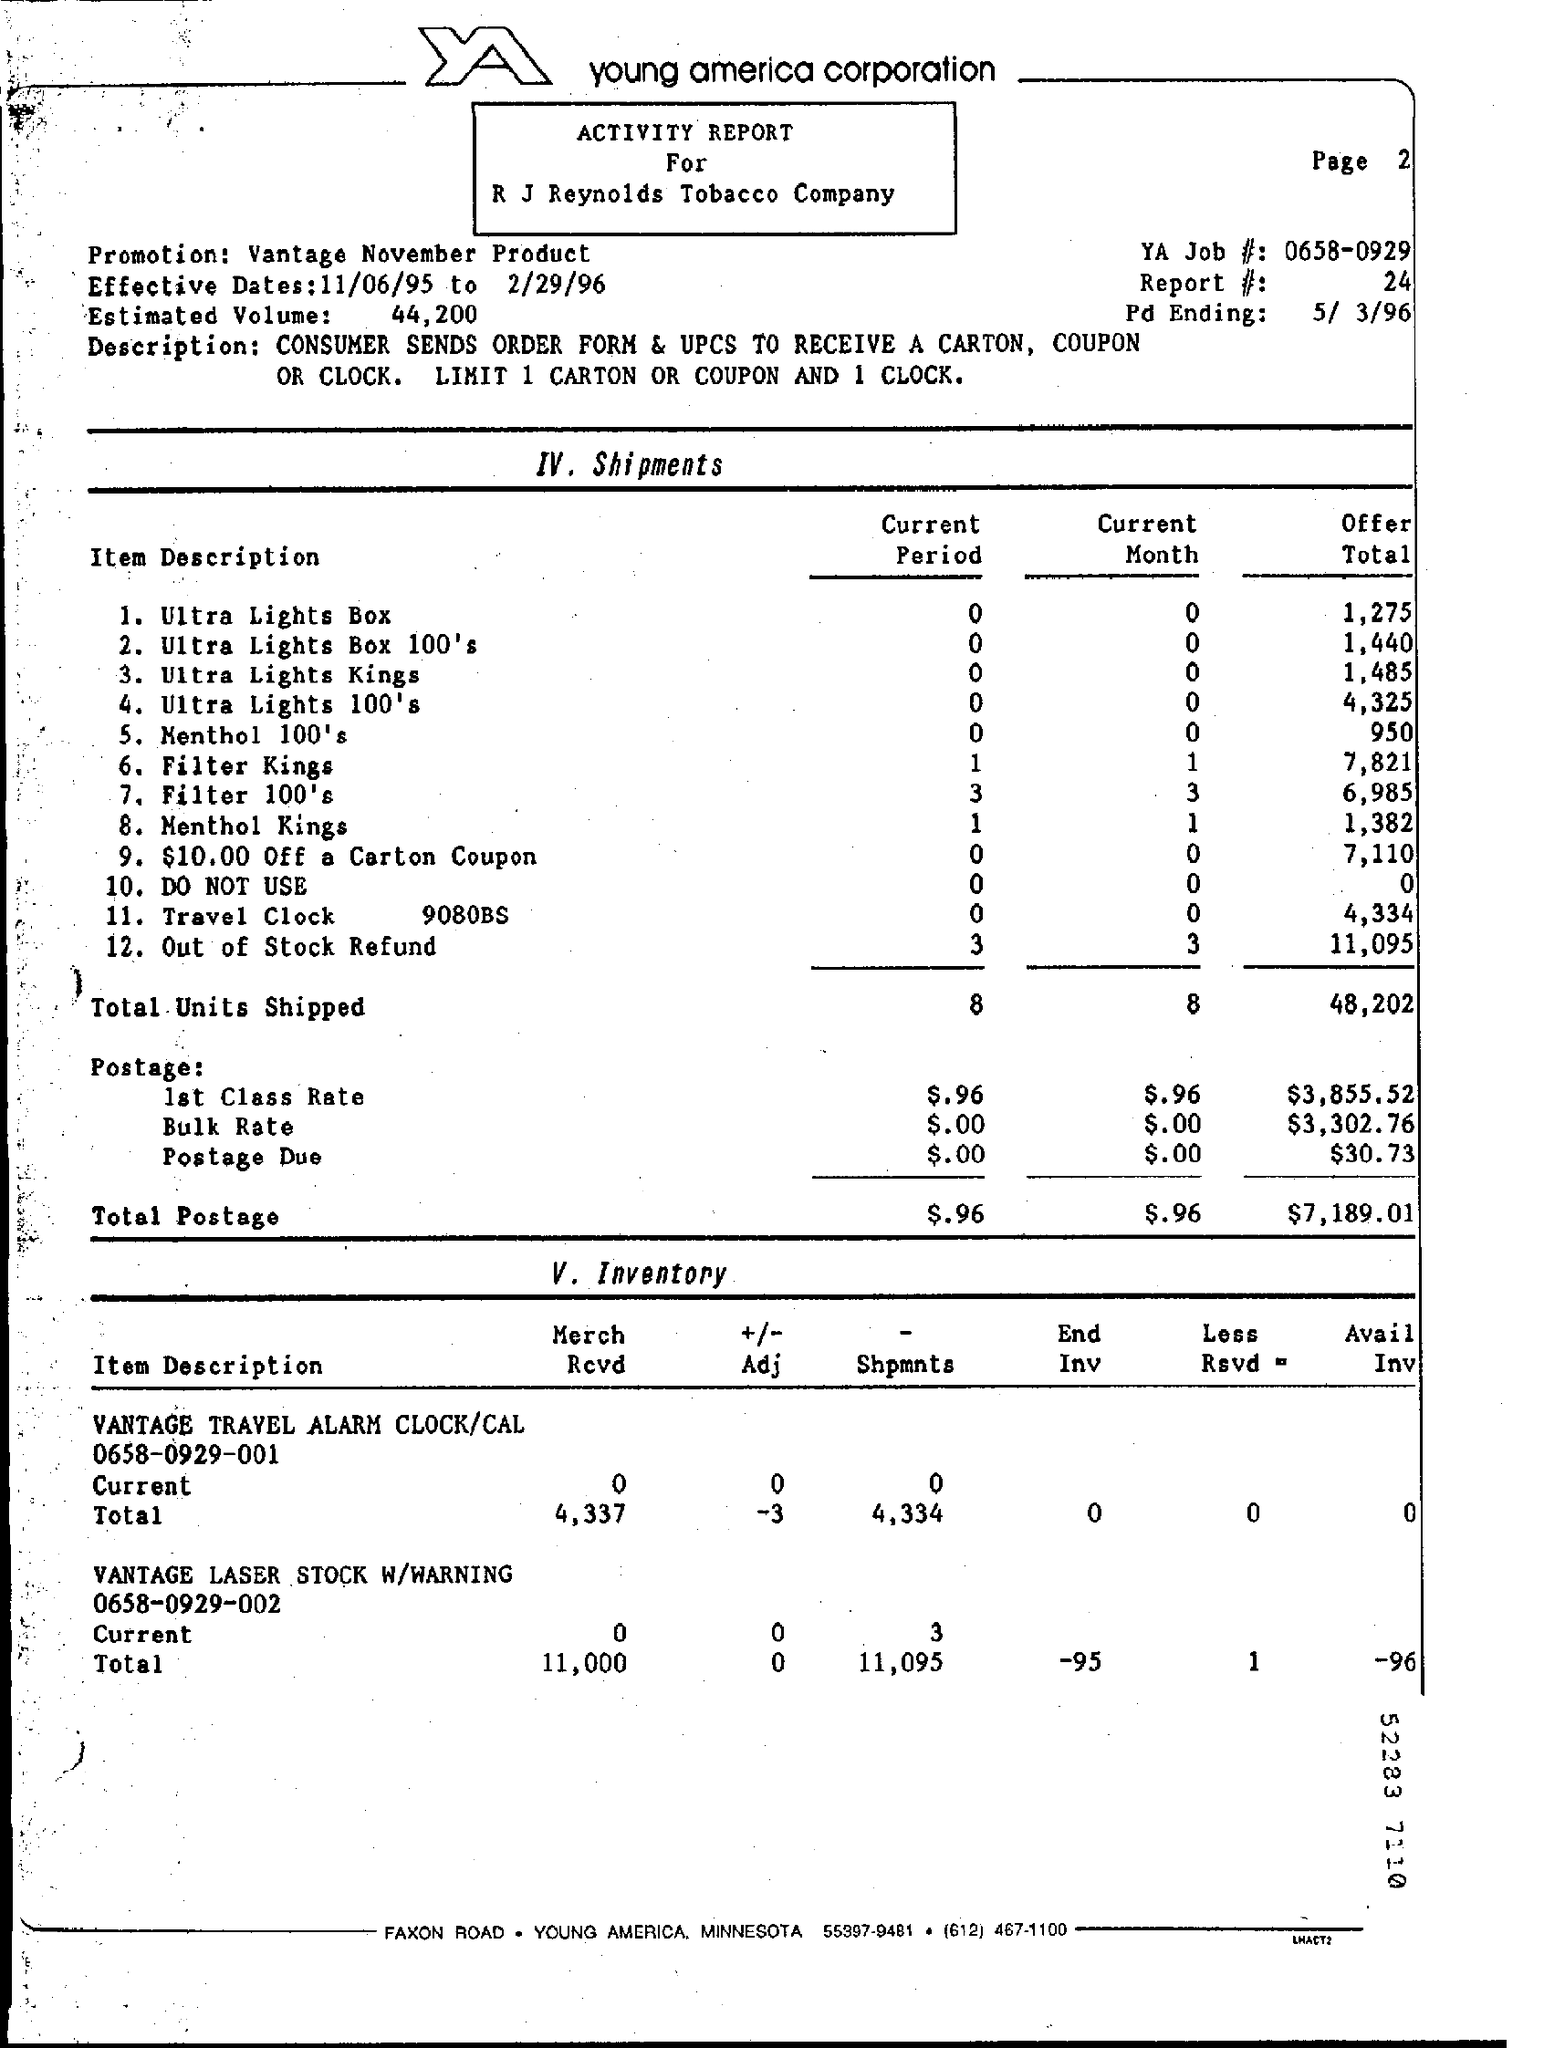List a handful of essential elements in this visual. The offer total value for the ultra light box is 1,275. The effective dates for the activity report are from 11/06/95 to 2/29/96. During the current period, the number of shipments of menthol cigarettes, specifically Menthol Kings, has been done. In the current month, a total of 8 units were shipped. In the current period, a total of 8 units have been shipped. 